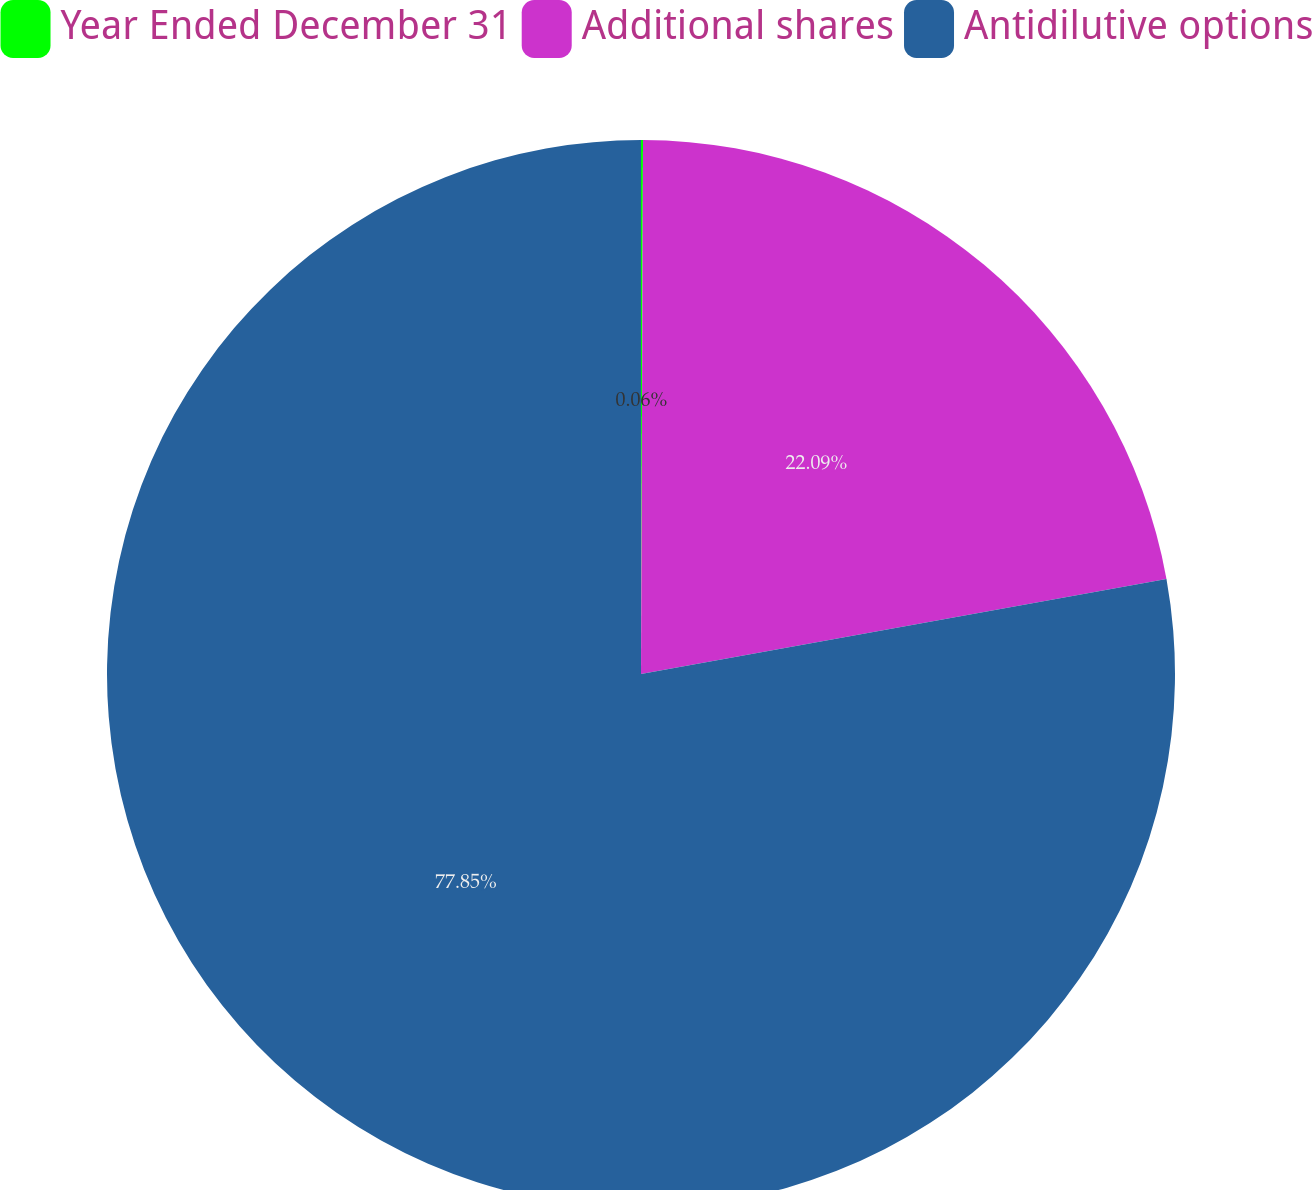<chart> <loc_0><loc_0><loc_500><loc_500><pie_chart><fcel>Year Ended December 31<fcel>Additional shares<fcel>Antidilutive options<nl><fcel>0.06%<fcel>22.09%<fcel>77.84%<nl></chart> 